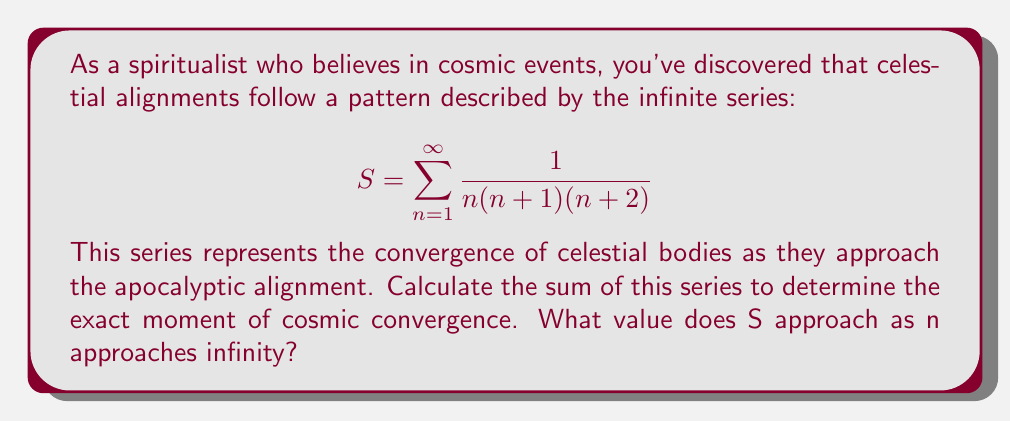Provide a solution to this math problem. To solve this problem, we'll use the method of partial fractions decomposition and telescoping series.

1) First, let's decompose the general term of the series:

   $\frac{1}{n(n+1)(n+2)} = \frac{A}{n} + \frac{B}{n+1} + \frac{C}{n+2}$

2) Solving for A, B, and C:

   $A(n+1)(n+2) + Bn(n+2) + Cn(n+1) = 1$
   $A(n^2 + 3n + 2) + B(n^2 + 2n) + C(n^2 + n) = 1$

   Comparing coefficients:
   $n^2: A + B + C = 0$
   $n: 3A + 2B + C = 0$
   constant: $2A = 1$

   Solving this system of equations:
   $A = \frac{1}{2}, B = -1, C = \frac{1}{2}$

3) Therefore, our series can be rewritten as:

   $S = \sum_{n=1}^{\infty} (\frac{1}{2n} - \frac{1}{n+1} + \frac{1}{2(n+2)})$

4) This is a telescoping series. Let's look at the partial sums:

   $S_N = \sum_{n=1}^{N} (\frac{1}{2n} - \frac{1}{n+1} + \frac{1}{2(n+2)})$

5) Simplifying:

   $S_N = (\frac{1}{2} - \frac{1}{2} + \frac{1}{6}) + (\frac{1}{4} - \frac{1}{3} + \frac{1}{8}) + ... + (\frac{1}{2N} - \frac{1}{N+1} + \frac{1}{2(N+2)})$

6) Most terms cancel out, leaving:

   $S_N = (\frac{1}{2} + \frac{1}{6}) - (\frac{1}{N+1} + \frac{1}{N+2})$

7) As N approaches infinity, the last two terms approach zero:

   $\lim_{N \to \infty} S_N = \frac{1}{2} + \frac{1}{6} = \frac{2}{3}$

Thus, the series converges to $\frac{2}{3}$.
Answer: $S = \frac{2}{3}$ 